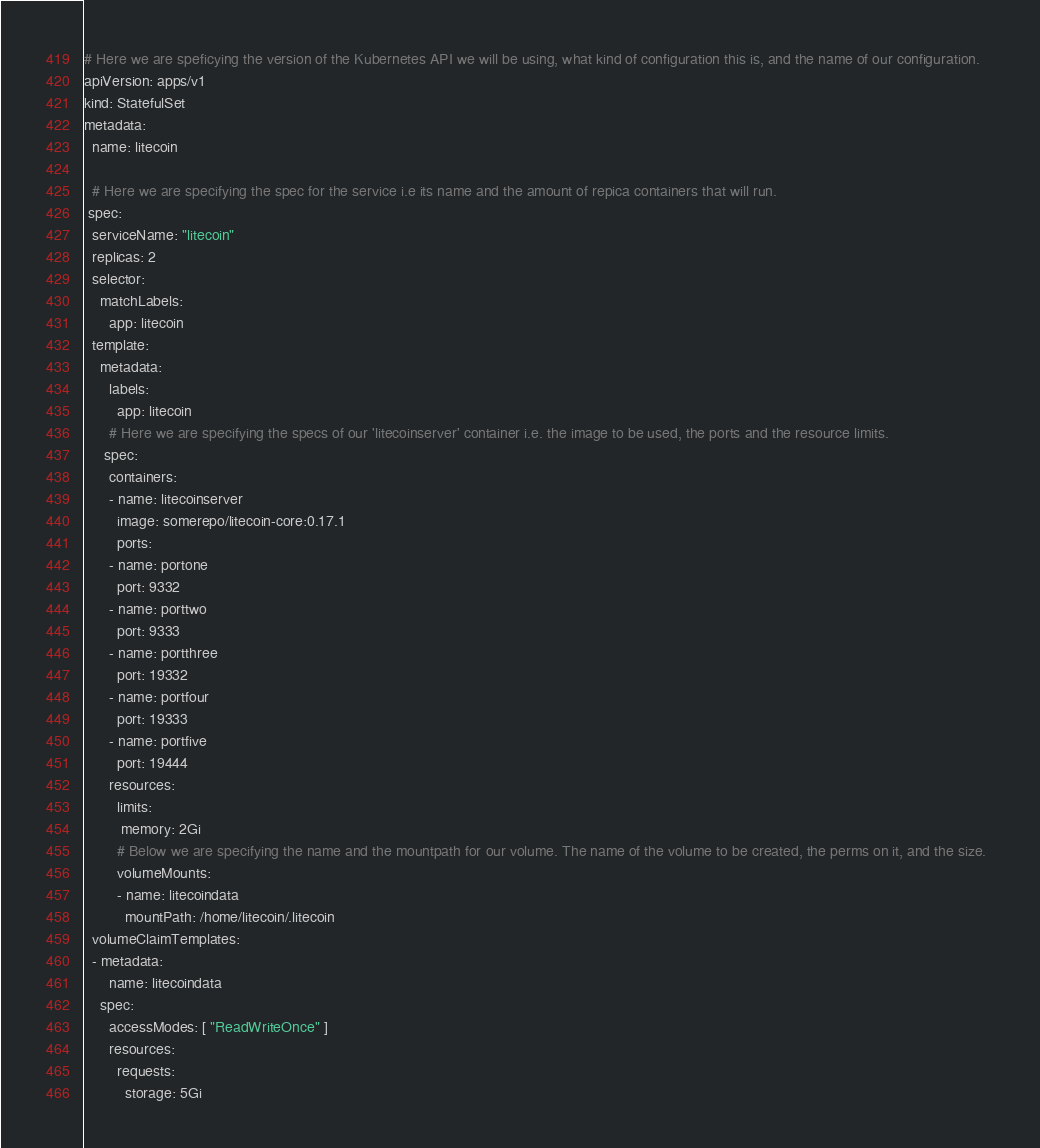<code> <loc_0><loc_0><loc_500><loc_500><_YAML_># Here we are speficying the version of the Kubernetes API we will be using, what kind of configuration this is, and the name of our configuration.
apiVersion: apps/v1
kind: StatefulSet
metadata:
  name: litecoin

  # Here we are specifying the spec for the service i.e its name and the amount of repica containers that will run.  
 spec:
  serviceName: "litecoin"
  replicas: 2
  selector:
    matchLabels:
      app: litecoin
  template:
    metadata:
      labels:
        app: litecoin       
      # Here we are specifying the specs of our 'litecoinserver' container i.e. the image to be used, the ports and the resource limits.   
     spec:
      containers:
      - name: litecoinserver
        image: somerepo/litecoin-core:0.17.1
        ports:
      - name: portone
        port: 9332
      - name: porttwo
        port: 9333
      - name: portthree
        port: 19332
      - name: portfour
        port: 19333
      - name: portfive
        port: 19444
      resources:
        limits:
         memory: 2Gi 
        # Below we are specifying the name and the mountpath for our volume. The name of the volume to be created, the perms on it, and the size.  
        volumeMounts:
        - name: litecoindata
          mountPath: /home/litecoin/.litecoin
  volumeClaimTemplates:
  - metadata:
      name: litecoindata
    spec:
      accessModes: [ "ReadWriteOnce" ]
      resources:
        requests:
          storage: 5Gi
</code> 